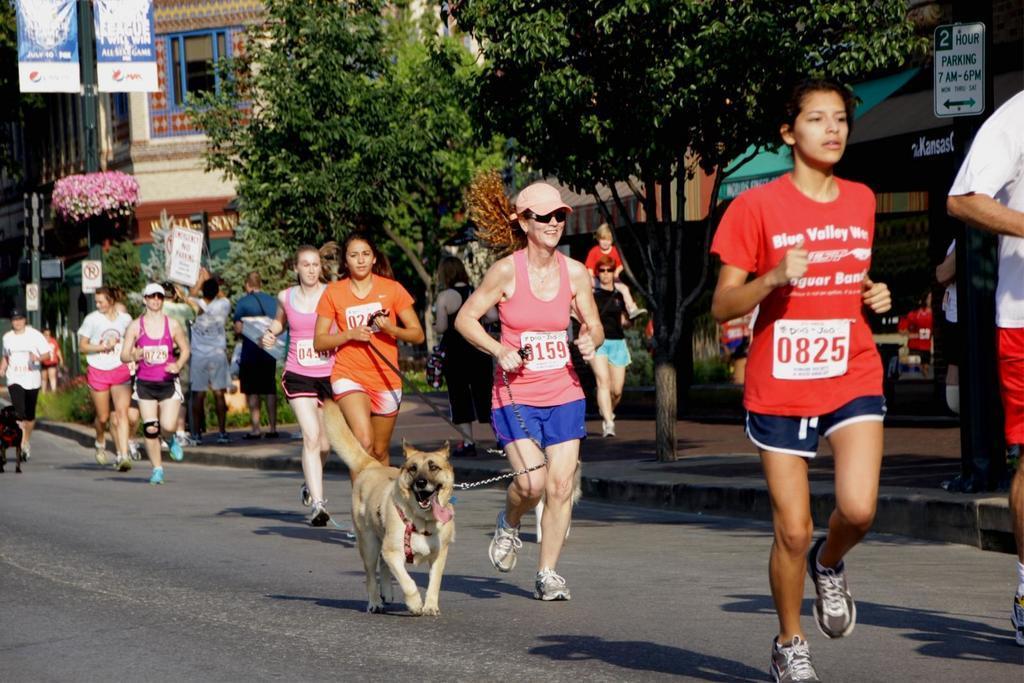Can you describe this image briefly? This is a picture of a marathon where we can a group of people running and a lady among them is holding dog's chain and also we can see some trees and flowers among them. 